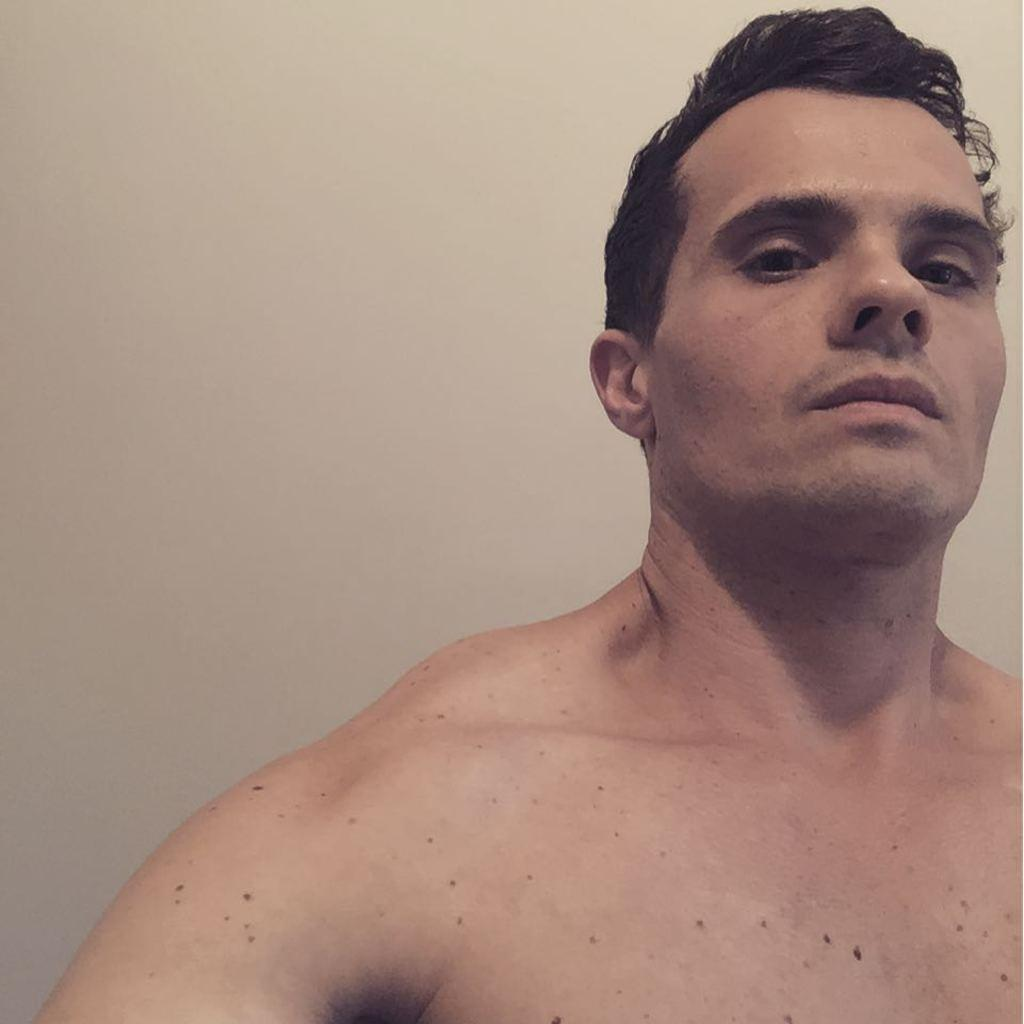What is the main subject of the image? The main subject of the image is a man. What distinguishing feature does the man have on his body? The man has black color spots on his body. What type of letters does the man have in his trousers in the image? There is no mention of letters or trousers in the image, and therefore no such information can be provided. 